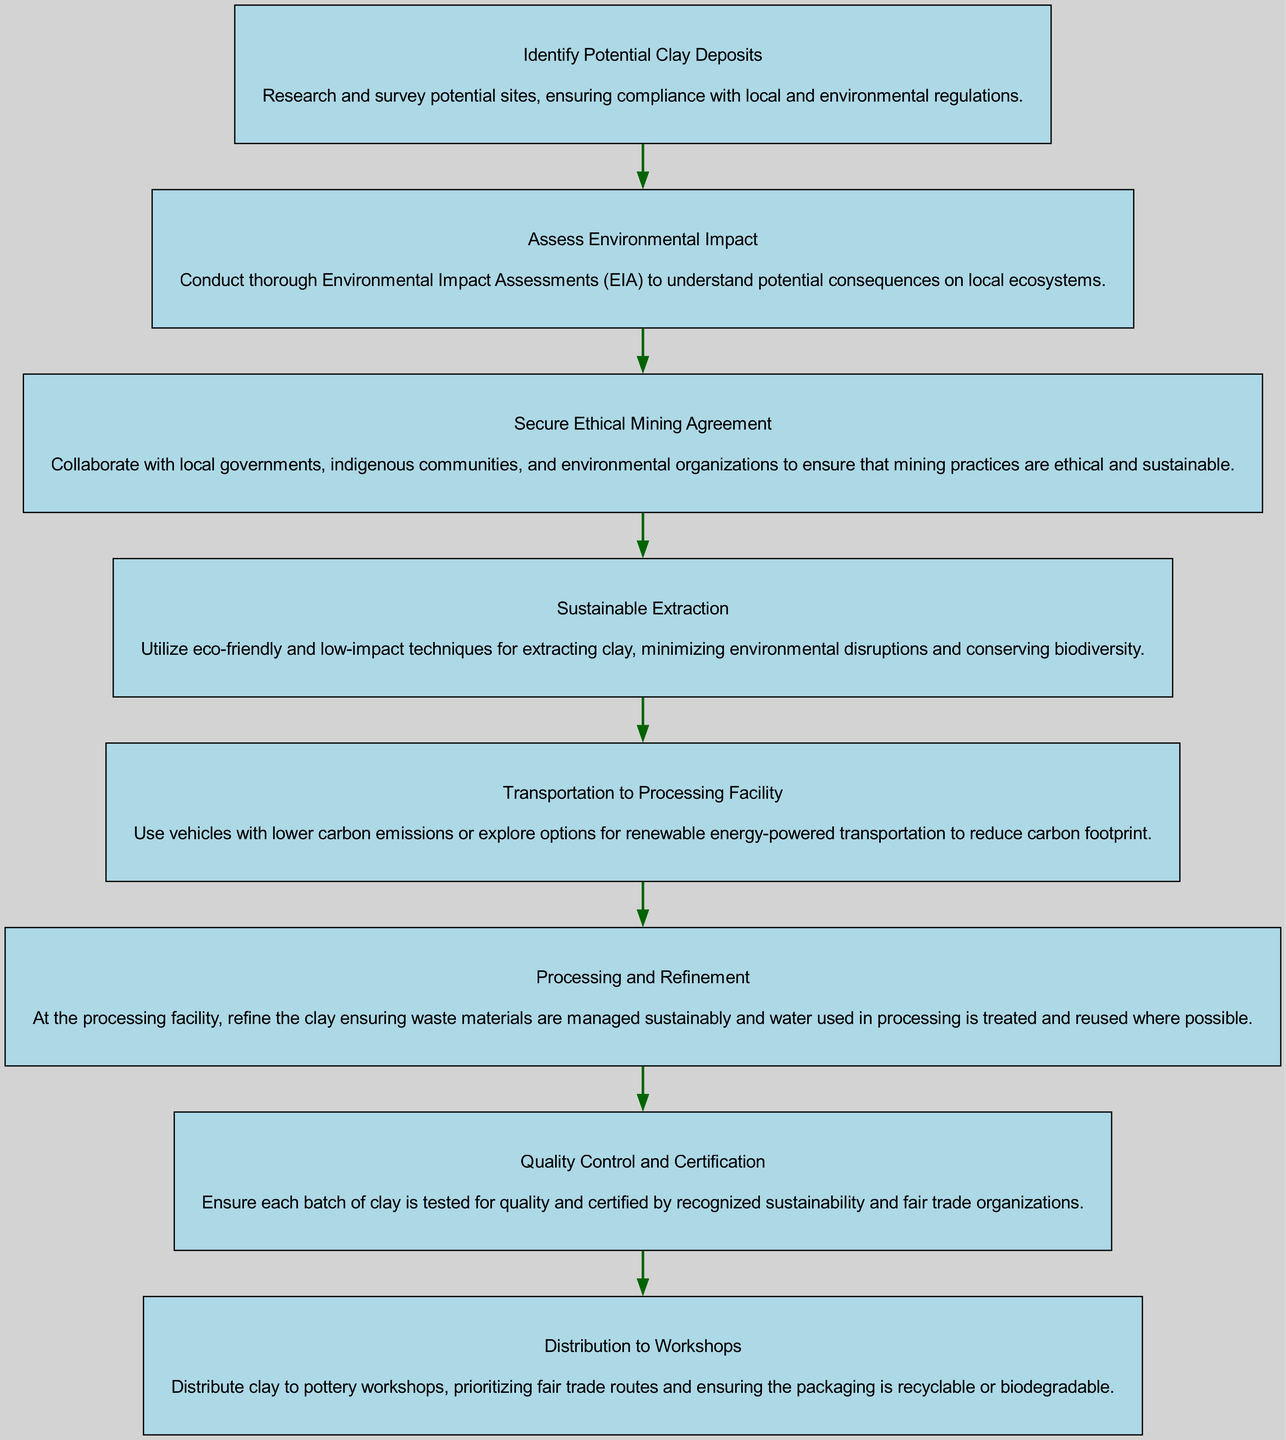What is the first step in the clay sourcing process? The first step is "Identify Potential Clay Deposits," which indicates that the initial phase involves researching possible clay sites.
Answer: Identify Potential Clay Deposits What follows after "Assess Environmental Impact"? After "Assess Environmental Impact," the next step is "Secure Ethical Mining Agreement," indicating that collaboration with stakeholders comes next.
Answer: Secure Ethical Mining Agreement How many total steps are there in the clay sourcing process? The diagram includes 8 distinct steps, listing various stages from identifying deposits to distributing the clay to workshops.
Answer: 8 Which step involves ensuring sustainability and fairness in mining practices? The step that focuses on sustainability and fairness in mining practices is "Secure Ethical Mining Agreement," where collaboration with relevant parties takes place.
Answer: Secure Ethical Mining Agreement What is the main focus during the "Processing and Refinement" step? The main focus during "Processing and Refinement" is to ensure the sustainable management of waste materials and the treatment of water used in the process.
Answer: Sustainable waste management Which step emphasizes low-impact extraction techniques? The step that emphasizes low-impact extraction techniques is "Sustainable Extraction," highlighting the use of eco-friendly methods during clay mining.
Answer: Sustainable Extraction What transportation approach is recommended before clay reaches the processing facility? The recommended transportation approach is to use vehicles with lower carbon emissions or renewable energy-powered options to reduce the carbon footprint.
Answer: Lower carbon emissions Which step directly precedes "Distribution to Workshops"? The step that directly precedes "Distribution to Workshops" is "Quality Control and Certification," which assures that each clay batch meets quality and sustainability standards.
Answer: Quality Control and Certification 